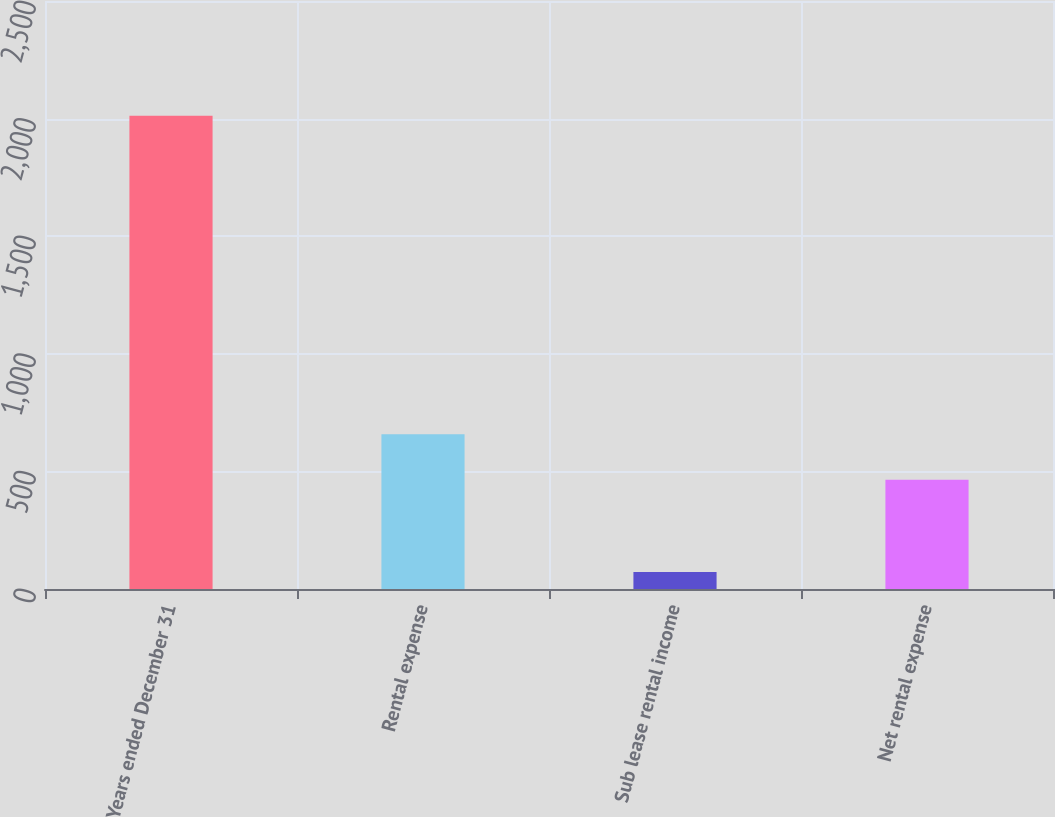Convert chart to OTSL. <chart><loc_0><loc_0><loc_500><loc_500><bar_chart><fcel>Years ended December 31<fcel>Rental expense<fcel>Sub lease rental income<fcel>Net rental expense<nl><fcel>2012<fcel>658<fcel>72<fcel>464<nl></chart> 